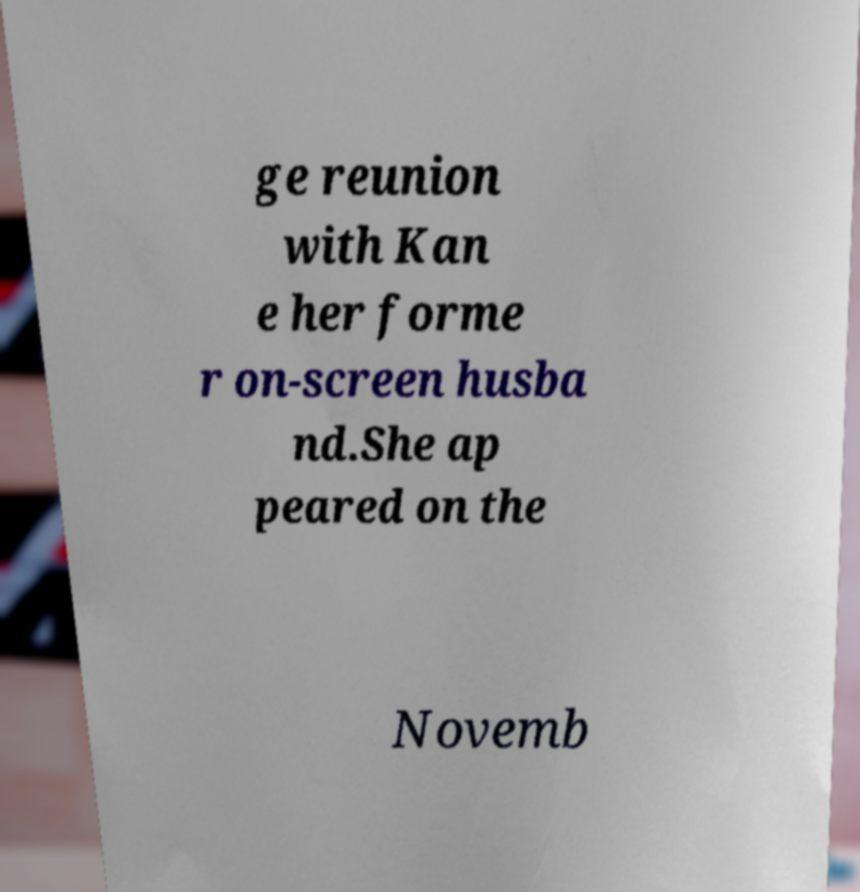I need the written content from this picture converted into text. Can you do that? ge reunion with Kan e her forme r on-screen husba nd.She ap peared on the Novemb 